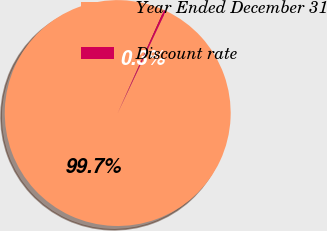Convert chart. <chart><loc_0><loc_0><loc_500><loc_500><pie_chart><fcel>Year Ended December 31<fcel>Discount rate<nl><fcel>99.71%<fcel>0.29%<nl></chart> 